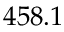Convert formula to latex. <formula><loc_0><loc_0><loc_500><loc_500>4 5 8 . 1</formula> 